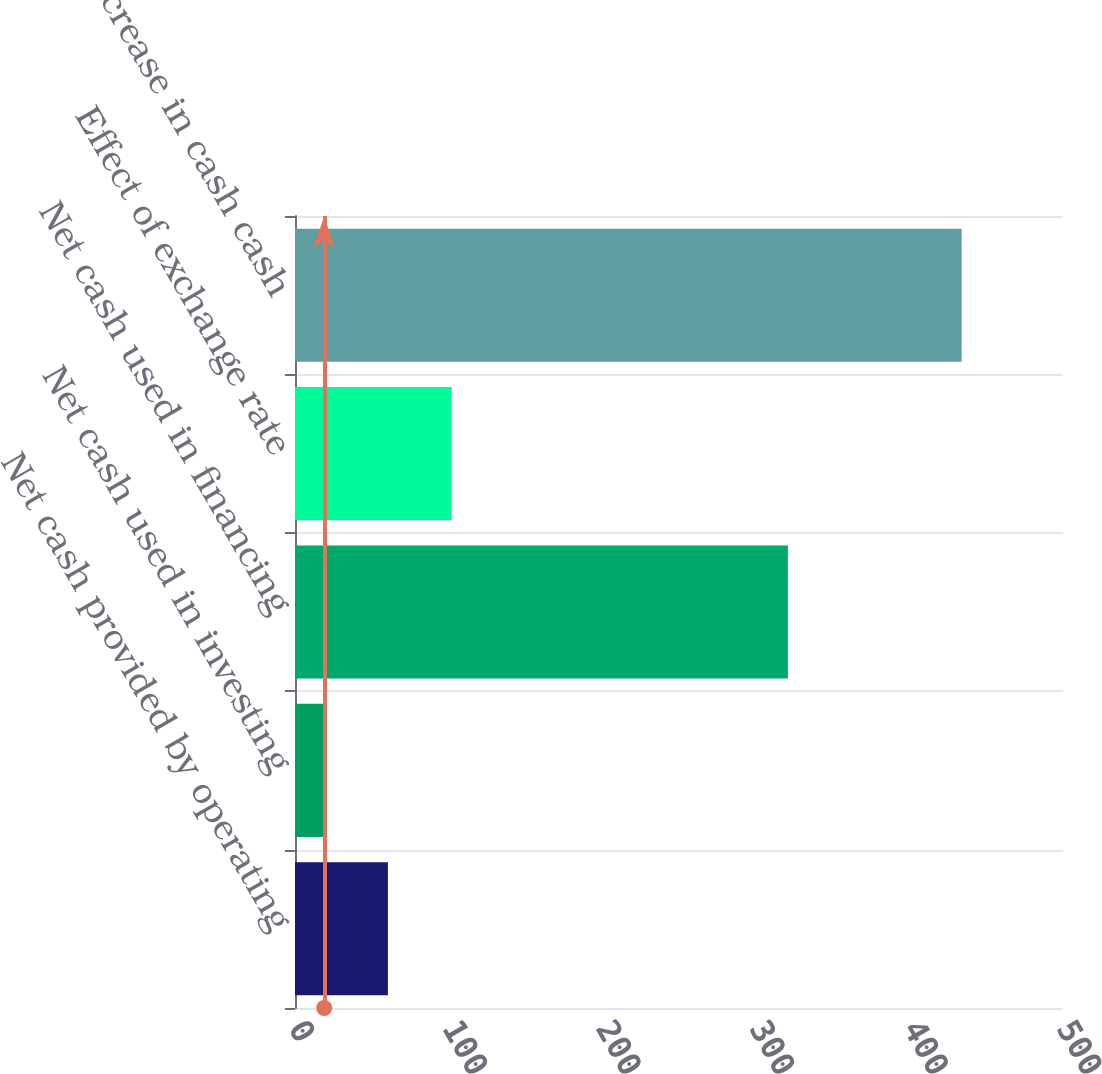<chart> <loc_0><loc_0><loc_500><loc_500><bar_chart><fcel>Net cash provided by operating<fcel>Net cash used in investing<fcel>Net cash used in financing<fcel>Effect of exchange rate<fcel>Net increase in cash cash<nl><fcel>60.5<fcel>19<fcel>320.9<fcel>102<fcel>434<nl></chart> 